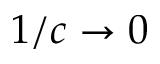<formula> <loc_0><loc_0><loc_500><loc_500>1 / c \rightarrow 0</formula> 